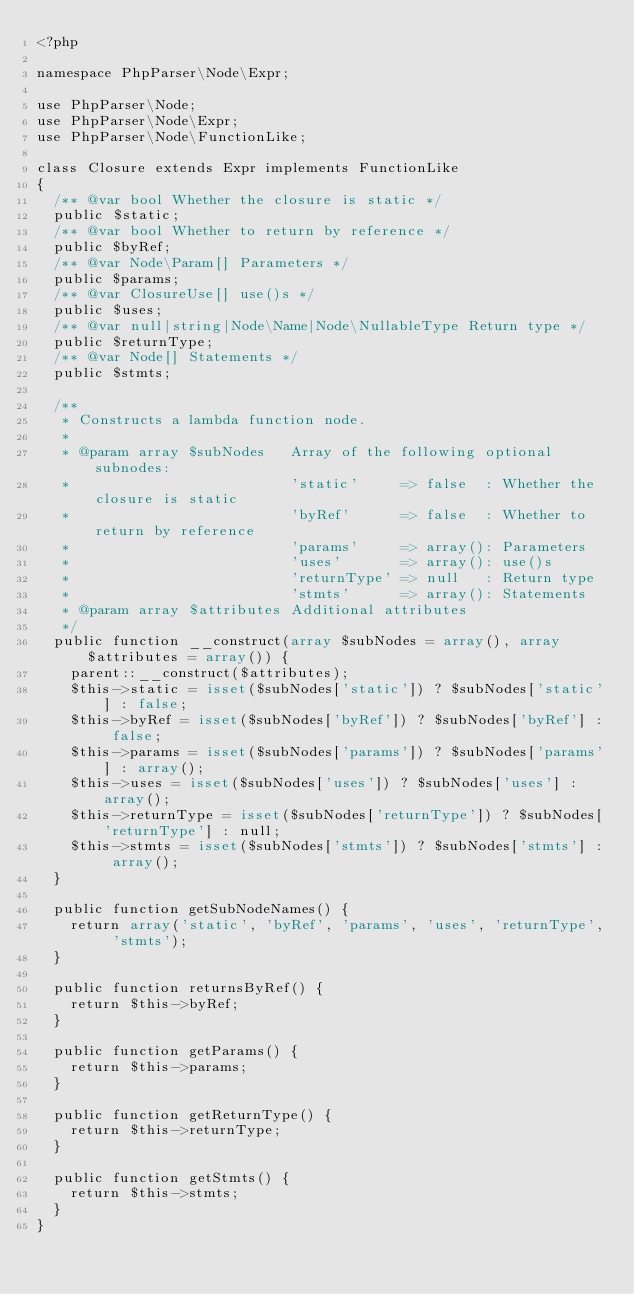Convert code to text. <code><loc_0><loc_0><loc_500><loc_500><_PHP_><?php

namespace PhpParser\Node\Expr;

use PhpParser\Node;
use PhpParser\Node\Expr;
use PhpParser\Node\FunctionLike;

class Closure extends Expr implements FunctionLike
{
	/** @var bool Whether the closure is static */
	public $static;
	/** @var bool Whether to return by reference */
	public $byRef;
	/** @var Node\Param[] Parameters */
	public $params;
	/** @var ClosureUse[] use()s */
	public $uses;
	/** @var null|string|Node\Name|Node\NullableType Return type */
	public $returnType;
	/** @var Node[] Statements */
	public $stmts;

	/**
	 * Constructs a lambda function node.
	 *
	 * @param array $subNodes   Array of the following optional subnodes:
	 *                          'static'     => false  : Whether the closure is static
	 *                          'byRef'      => false  : Whether to return by reference
	 *                          'params'     => array(): Parameters
	 *                          'uses'       => array(): use()s
	 *                          'returnType' => null   : Return type
	 *                          'stmts'      => array(): Statements
	 * @param array $attributes Additional attributes
	 */
	public function __construct(array $subNodes = array(), array $attributes = array()) {
		parent::__construct($attributes);
		$this->static = isset($subNodes['static']) ? $subNodes['static'] : false;
		$this->byRef = isset($subNodes['byRef']) ? $subNodes['byRef'] : false;
		$this->params = isset($subNodes['params']) ? $subNodes['params'] : array();
		$this->uses = isset($subNodes['uses']) ? $subNodes['uses'] : array();
		$this->returnType = isset($subNodes['returnType']) ? $subNodes['returnType'] : null;
		$this->stmts = isset($subNodes['stmts']) ? $subNodes['stmts'] : array();
	}

	public function getSubNodeNames() {
		return array('static', 'byRef', 'params', 'uses', 'returnType', 'stmts');
	}

	public function returnsByRef() {
		return $this->byRef;
	}

	public function getParams() {
		return $this->params;
	}

	public function getReturnType() {
		return $this->returnType;
	}

	public function getStmts() {
		return $this->stmts;
	}
}
</code> 